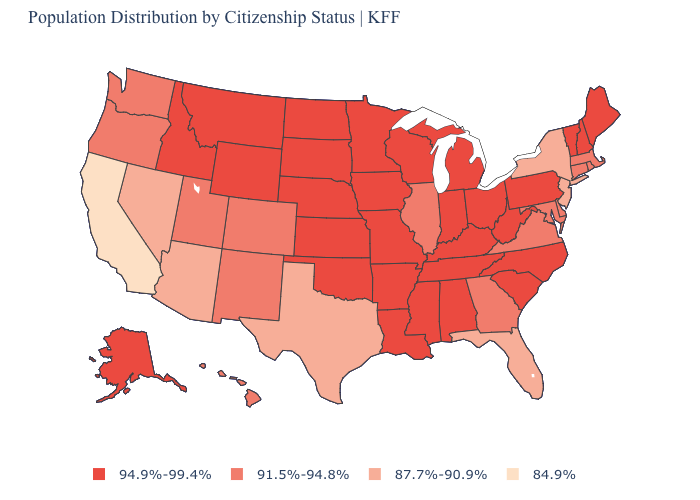Does Michigan have the lowest value in the USA?
Answer briefly. No. Does South Carolina have the same value as Alabama?
Keep it brief. Yes. Name the states that have a value in the range 84.9%?
Concise answer only. California. Among the states that border Virginia , does Kentucky have the lowest value?
Give a very brief answer. No. Name the states that have a value in the range 87.7%-90.9%?
Short answer required. Arizona, Florida, Nevada, New Jersey, New York, Texas. What is the lowest value in states that border Florida?
Quick response, please. 91.5%-94.8%. Name the states that have a value in the range 87.7%-90.9%?
Give a very brief answer. Arizona, Florida, Nevada, New Jersey, New York, Texas. What is the value of Arkansas?
Be succinct. 94.9%-99.4%. Does New York have the highest value in the Northeast?
Answer briefly. No. What is the value of Louisiana?
Answer briefly. 94.9%-99.4%. Name the states that have a value in the range 87.7%-90.9%?
Write a very short answer. Arizona, Florida, Nevada, New Jersey, New York, Texas. Does Wisconsin have a higher value than New Mexico?
Answer briefly. Yes. What is the value of Mississippi?
Keep it brief. 94.9%-99.4%. Name the states that have a value in the range 94.9%-99.4%?
Quick response, please. Alabama, Alaska, Arkansas, Idaho, Indiana, Iowa, Kansas, Kentucky, Louisiana, Maine, Michigan, Minnesota, Mississippi, Missouri, Montana, Nebraska, New Hampshire, North Carolina, North Dakota, Ohio, Oklahoma, Pennsylvania, South Carolina, South Dakota, Tennessee, Vermont, West Virginia, Wisconsin, Wyoming. Is the legend a continuous bar?
Give a very brief answer. No. 